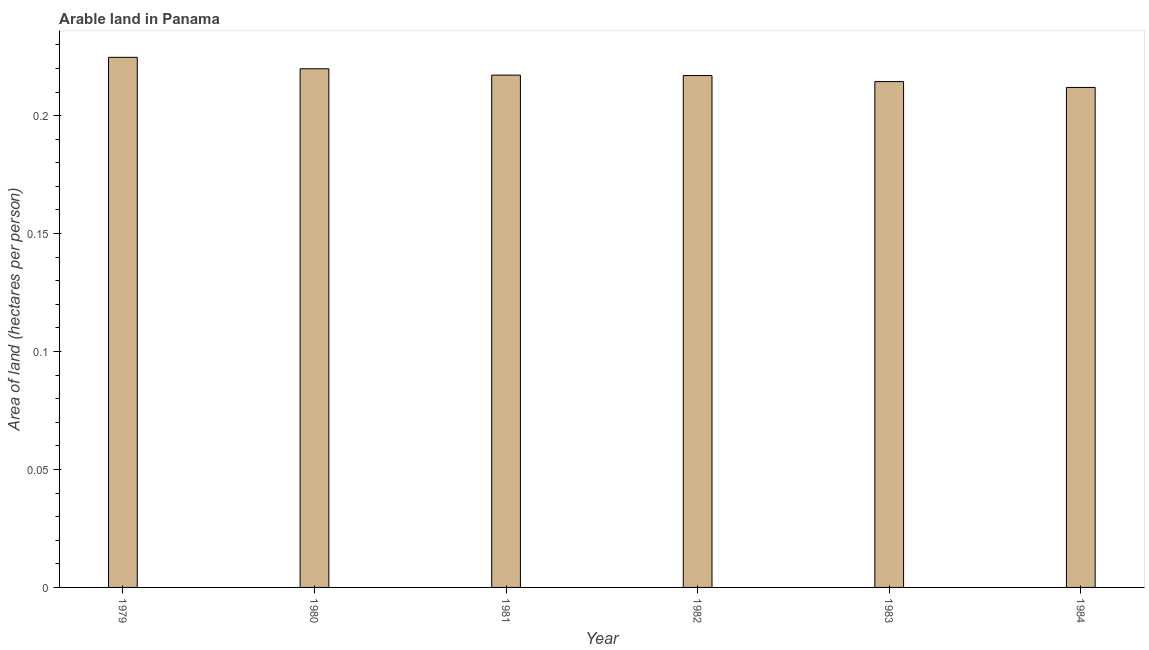Does the graph contain any zero values?
Your answer should be very brief. No. Does the graph contain grids?
Provide a short and direct response. No. What is the title of the graph?
Your response must be concise. Arable land in Panama. What is the label or title of the Y-axis?
Provide a succinct answer. Area of land (hectares per person). What is the area of arable land in 1980?
Give a very brief answer. 0.22. Across all years, what is the maximum area of arable land?
Ensure brevity in your answer.  0.22. Across all years, what is the minimum area of arable land?
Keep it short and to the point. 0.21. In which year was the area of arable land maximum?
Your answer should be compact. 1979. What is the sum of the area of arable land?
Your response must be concise. 1.31. What is the average area of arable land per year?
Provide a short and direct response. 0.22. What is the median area of arable land?
Ensure brevity in your answer.  0.22. Do a majority of the years between 1980 and 1981 (inclusive) have area of arable land greater than 0.06 hectares per person?
Your response must be concise. Yes. Is the area of arable land in 1981 less than that in 1984?
Your response must be concise. No. What is the difference between the highest and the second highest area of arable land?
Keep it short and to the point. 0.01. Is the sum of the area of arable land in 1983 and 1984 greater than the maximum area of arable land across all years?
Provide a short and direct response. Yes. In how many years, is the area of arable land greater than the average area of arable land taken over all years?
Ensure brevity in your answer.  2. How many bars are there?
Keep it short and to the point. 6. How many years are there in the graph?
Your answer should be very brief. 6. What is the difference between two consecutive major ticks on the Y-axis?
Provide a short and direct response. 0.05. What is the Area of land (hectares per person) of 1979?
Provide a short and direct response. 0.22. What is the Area of land (hectares per person) of 1980?
Your answer should be very brief. 0.22. What is the Area of land (hectares per person) of 1981?
Make the answer very short. 0.22. What is the Area of land (hectares per person) of 1982?
Make the answer very short. 0.22. What is the Area of land (hectares per person) of 1983?
Offer a terse response. 0.21. What is the Area of land (hectares per person) in 1984?
Keep it short and to the point. 0.21. What is the difference between the Area of land (hectares per person) in 1979 and 1980?
Your answer should be very brief. 0. What is the difference between the Area of land (hectares per person) in 1979 and 1981?
Ensure brevity in your answer.  0.01. What is the difference between the Area of land (hectares per person) in 1979 and 1982?
Give a very brief answer. 0.01. What is the difference between the Area of land (hectares per person) in 1979 and 1983?
Offer a terse response. 0.01. What is the difference between the Area of land (hectares per person) in 1979 and 1984?
Provide a succinct answer. 0.01. What is the difference between the Area of land (hectares per person) in 1980 and 1981?
Provide a short and direct response. 0. What is the difference between the Area of land (hectares per person) in 1980 and 1982?
Make the answer very short. 0. What is the difference between the Area of land (hectares per person) in 1980 and 1983?
Keep it short and to the point. 0.01. What is the difference between the Area of land (hectares per person) in 1980 and 1984?
Your answer should be compact. 0.01. What is the difference between the Area of land (hectares per person) in 1981 and 1982?
Provide a short and direct response. 0. What is the difference between the Area of land (hectares per person) in 1981 and 1983?
Offer a very short reply. 0. What is the difference between the Area of land (hectares per person) in 1981 and 1984?
Provide a succinct answer. 0.01. What is the difference between the Area of land (hectares per person) in 1982 and 1983?
Your answer should be very brief. 0. What is the difference between the Area of land (hectares per person) in 1982 and 1984?
Provide a succinct answer. 0.01. What is the difference between the Area of land (hectares per person) in 1983 and 1984?
Make the answer very short. 0. What is the ratio of the Area of land (hectares per person) in 1979 to that in 1981?
Offer a very short reply. 1.03. What is the ratio of the Area of land (hectares per person) in 1979 to that in 1982?
Give a very brief answer. 1.04. What is the ratio of the Area of land (hectares per person) in 1979 to that in 1983?
Make the answer very short. 1.05. What is the ratio of the Area of land (hectares per person) in 1979 to that in 1984?
Your answer should be compact. 1.06. What is the ratio of the Area of land (hectares per person) in 1980 to that in 1983?
Give a very brief answer. 1.02. What is the ratio of the Area of land (hectares per person) in 1981 to that in 1982?
Provide a short and direct response. 1. What is the ratio of the Area of land (hectares per person) in 1982 to that in 1984?
Offer a terse response. 1.02. What is the ratio of the Area of land (hectares per person) in 1983 to that in 1984?
Provide a succinct answer. 1.01. 